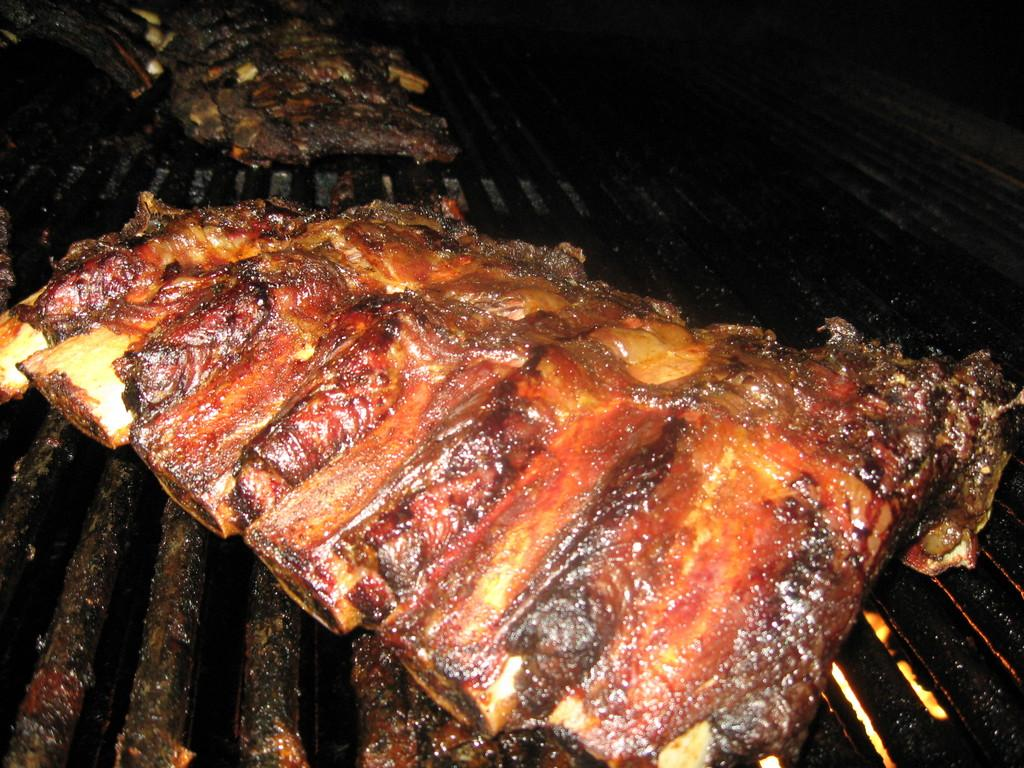What type of food can be seen in the image? There is meat on grills in the image. What type of stitch is used to create the design on the meat in the image? There is no design or stitching present on the meat in the image; it is simply grilled meat. 